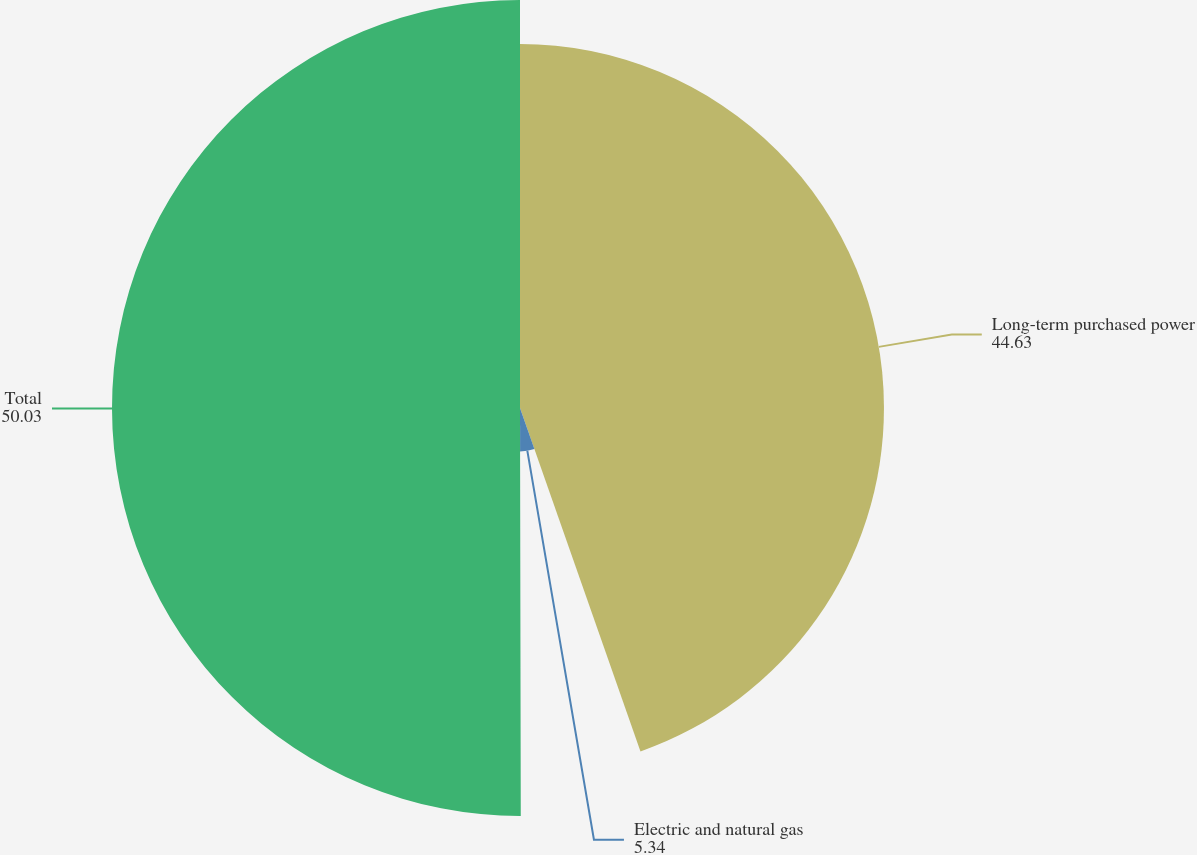<chart> <loc_0><loc_0><loc_500><loc_500><pie_chart><fcel>Long-term purchased power<fcel>Electric and natural gas<fcel>Total<nl><fcel>44.63%<fcel>5.34%<fcel>50.03%<nl></chart> 